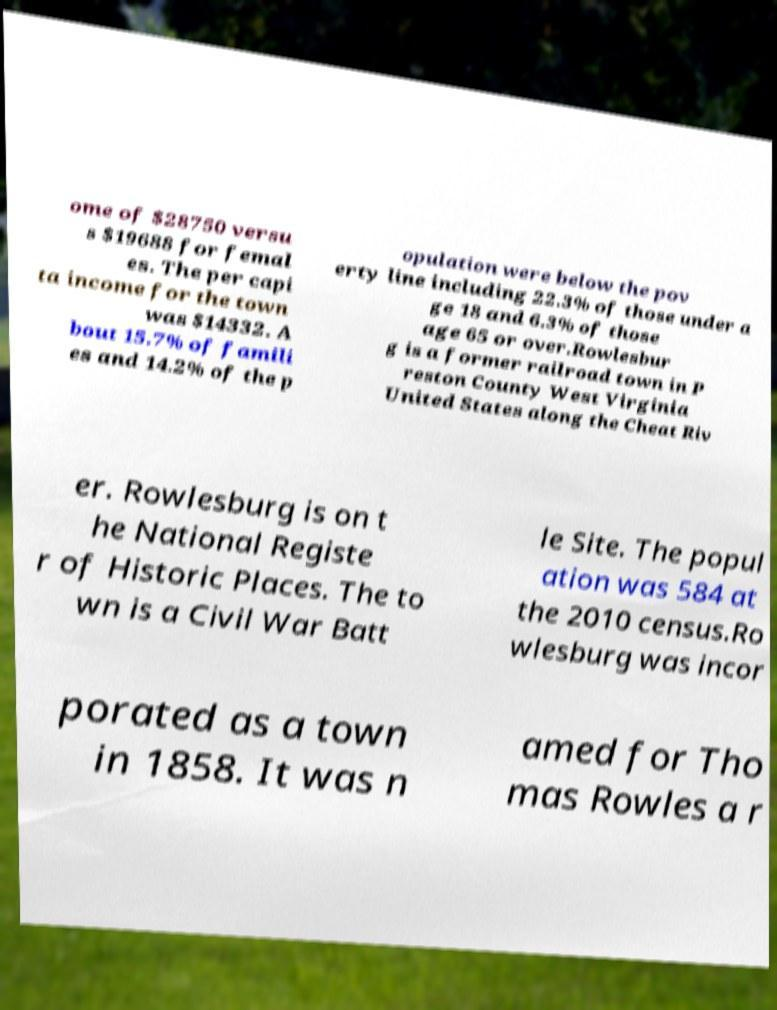For documentation purposes, I need the text within this image transcribed. Could you provide that? ome of $28750 versu s $19688 for femal es. The per capi ta income for the town was $14332. A bout 15.7% of famili es and 14.2% of the p opulation were below the pov erty line including 22.3% of those under a ge 18 and 6.3% of those age 65 or over.Rowlesbur g is a former railroad town in P reston County West Virginia United States along the Cheat Riv er. Rowlesburg is on t he National Registe r of Historic Places. The to wn is a Civil War Batt le Site. The popul ation was 584 at the 2010 census.Ro wlesburg was incor porated as a town in 1858. It was n amed for Tho mas Rowles a r 